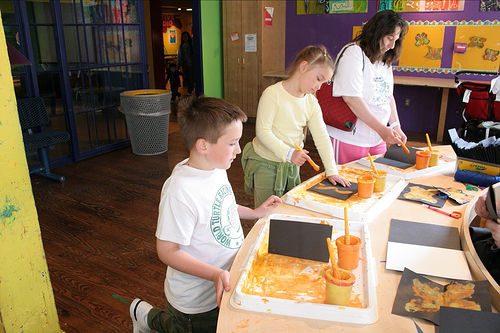<image>
Can you confirm if the boy is behind the girl? No. The boy is not behind the girl. From this viewpoint, the boy appears to be positioned elsewhere in the scene. Where is the trashcan in relation to the boy? Is it next to the boy? No. The trashcan is not positioned next to the boy. They are located in different areas of the scene. 